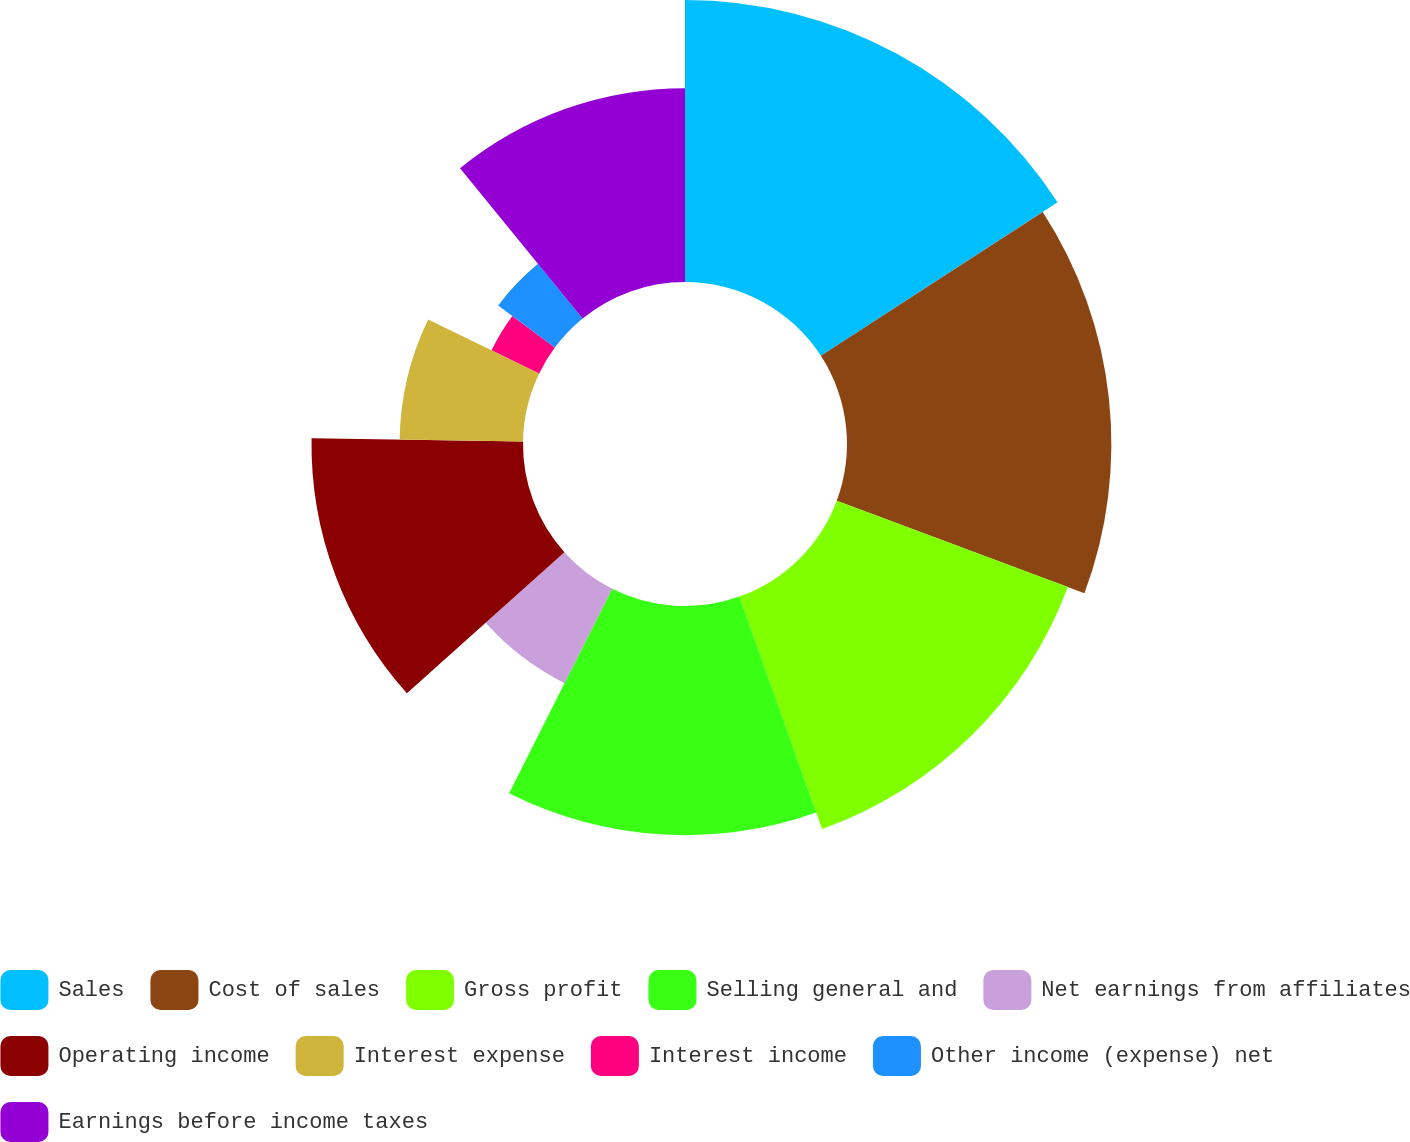Convert chart. <chart><loc_0><loc_0><loc_500><loc_500><pie_chart><fcel>Sales<fcel>Cost of sales<fcel>Gross profit<fcel>Selling general and<fcel>Net earnings from affiliates<fcel>Operating income<fcel>Interest expense<fcel>Interest income<fcel>Other income (expense) net<fcel>Earnings before income taxes<nl><fcel>15.84%<fcel>14.85%<fcel>13.86%<fcel>12.87%<fcel>5.94%<fcel>11.88%<fcel>6.93%<fcel>2.97%<fcel>3.96%<fcel>10.89%<nl></chart> 